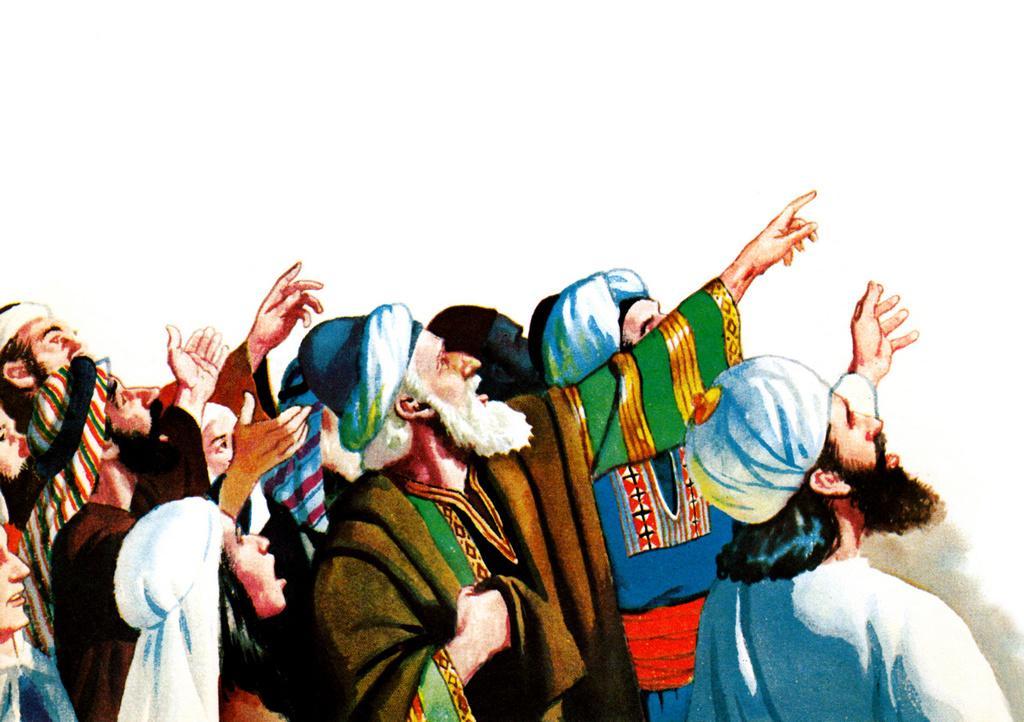In one or two sentences, can you explain what this image depicts? As we can see in the image there is painting of few people. 